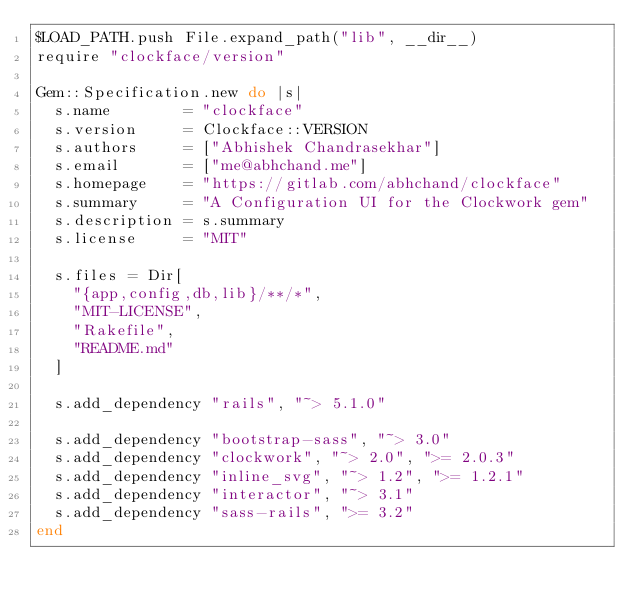<code> <loc_0><loc_0><loc_500><loc_500><_Ruby_>$LOAD_PATH.push File.expand_path("lib", __dir__)
require "clockface/version"

Gem::Specification.new do |s|
  s.name        = "clockface"
  s.version     = Clockface::VERSION
  s.authors     = ["Abhishek Chandrasekhar"]
  s.email       = ["me@abhchand.me"]
  s.homepage    = "https://gitlab.com/abhchand/clockface"
  s.summary     = "A Configuration UI for the Clockwork gem"
  s.description = s.summary
  s.license     = "MIT"

  s.files = Dir[
    "{app,config,db,lib}/**/*",
    "MIT-LICENSE",
    "Rakefile",
    "README.md"
  ]

  s.add_dependency "rails", "~> 5.1.0"

  s.add_dependency "bootstrap-sass", "~> 3.0"
  s.add_dependency "clockwork", "~> 2.0", ">= 2.0.3"
  s.add_dependency "inline_svg", "~> 1.2", ">= 1.2.1"
  s.add_dependency "interactor", "~> 3.1"
  s.add_dependency "sass-rails", ">= 3.2"
end
</code> 